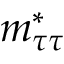<formula> <loc_0><loc_0><loc_500><loc_500>m _ { \tau \tau } ^ { * }</formula> 